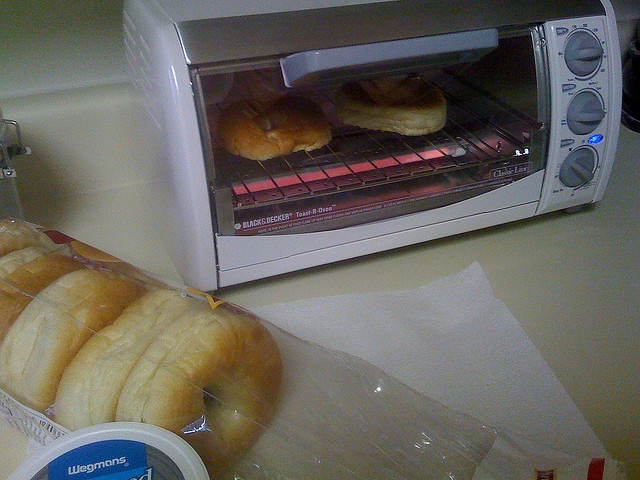Describe the objects in this image and their specific colors. I can see oven in darkgreen, black, darkgray, gray, and maroon tones, donut in darkgreen, olive, tan, gray, and maroon tones, donut in darkgreen, tan, darkgray, and olive tones, donut in darkgreen, tan, darkgray, gray, and olive tones, and donut in darkgreen, black, maroon, and olive tones in this image. 